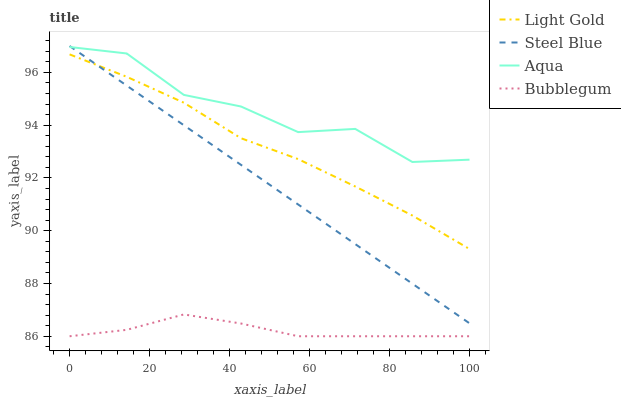Does Bubblegum have the minimum area under the curve?
Answer yes or no. Yes. Does Aqua have the maximum area under the curve?
Answer yes or no. Yes. Does Light Gold have the minimum area under the curve?
Answer yes or no. No. Does Light Gold have the maximum area under the curve?
Answer yes or no. No. Is Steel Blue the smoothest?
Answer yes or no. Yes. Is Aqua the roughest?
Answer yes or no. Yes. Is Light Gold the smoothest?
Answer yes or no. No. Is Light Gold the roughest?
Answer yes or no. No. Does Bubblegum have the lowest value?
Answer yes or no. Yes. Does Light Gold have the lowest value?
Answer yes or no. No. Does Steel Blue have the highest value?
Answer yes or no. Yes. Does Light Gold have the highest value?
Answer yes or no. No. Is Bubblegum less than Steel Blue?
Answer yes or no. Yes. Is Aqua greater than Light Gold?
Answer yes or no. Yes. Does Steel Blue intersect Light Gold?
Answer yes or no. Yes. Is Steel Blue less than Light Gold?
Answer yes or no. No. Is Steel Blue greater than Light Gold?
Answer yes or no. No. Does Bubblegum intersect Steel Blue?
Answer yes or no. No. 